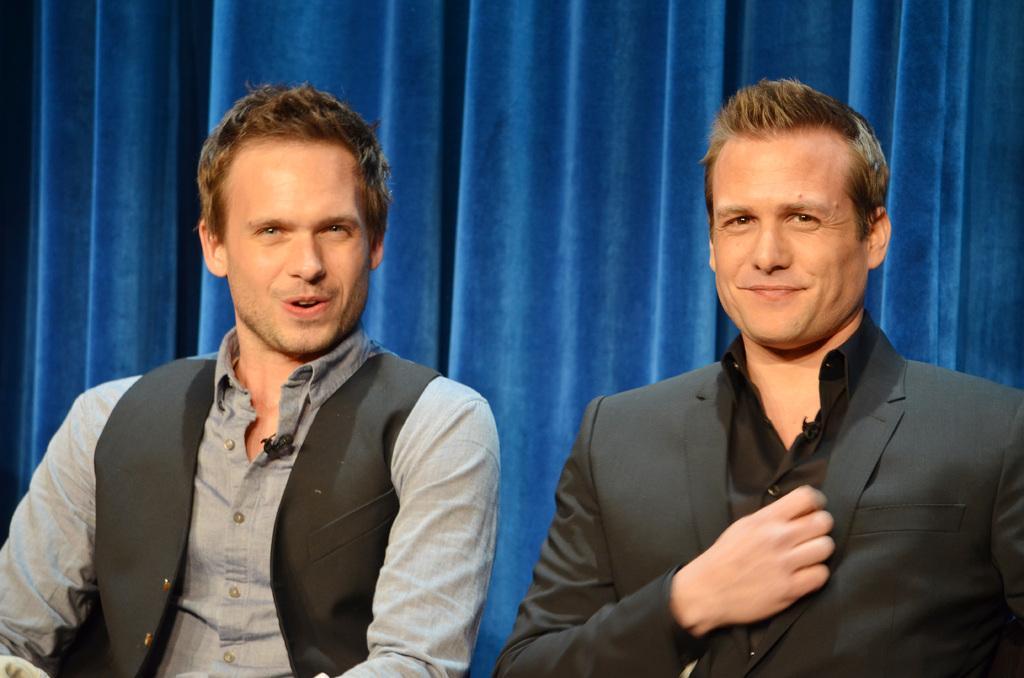How would you summarize this image in a sentence or two? In this picture I can see two persons sitting, and in the background it is looking like a curtain. 